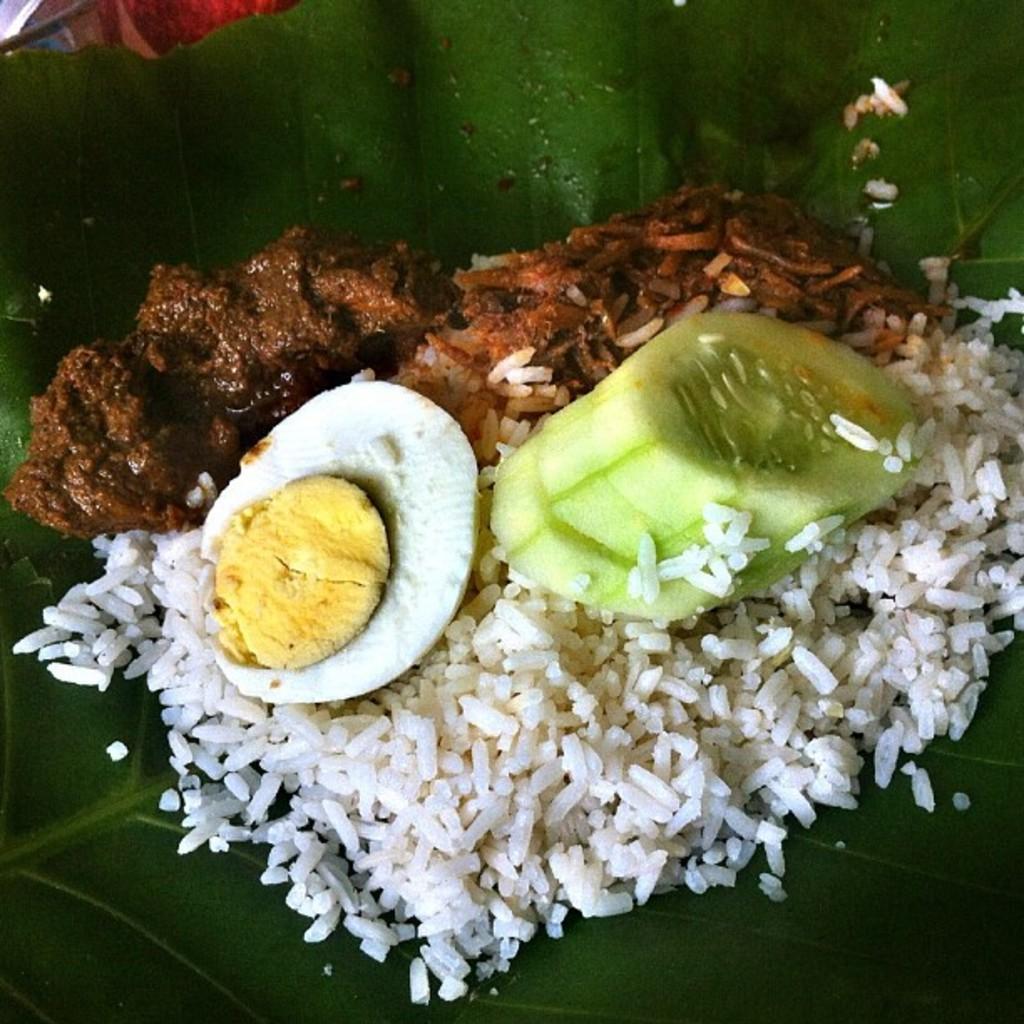In one or two sentences, can you explain what this image depicts? In this image we can see some food on the leaf. There is an egg, few pieces of cucumber and the rice in the image. 